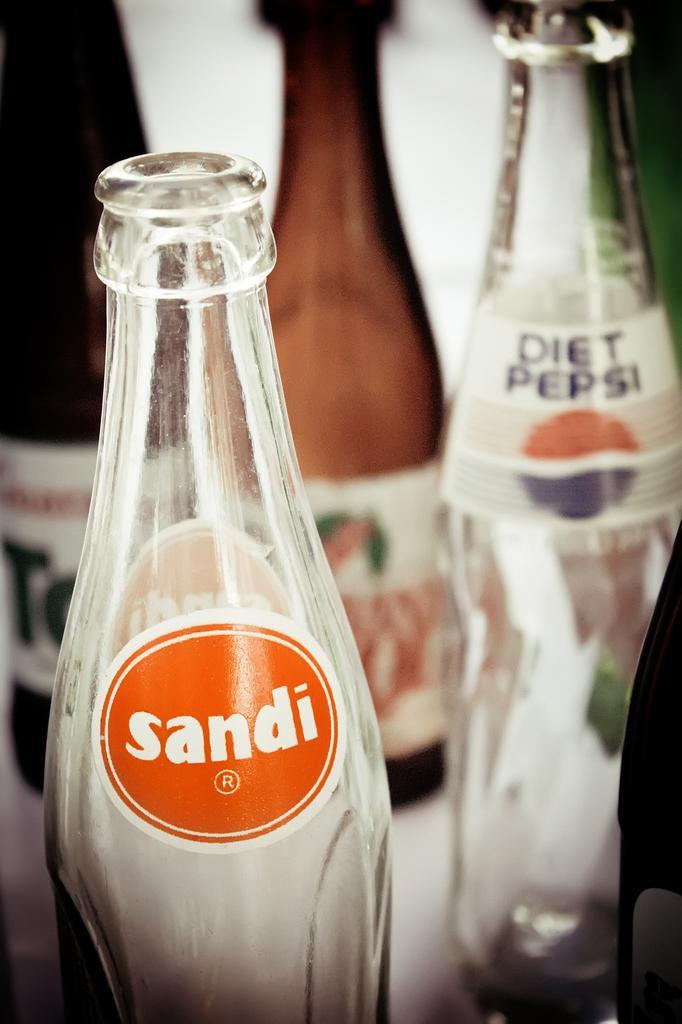Please provide a concise description of this image. In this picture, we see two brown bottles and two white glass bottles. On these bottles, we see a sticker with some text written on it. 